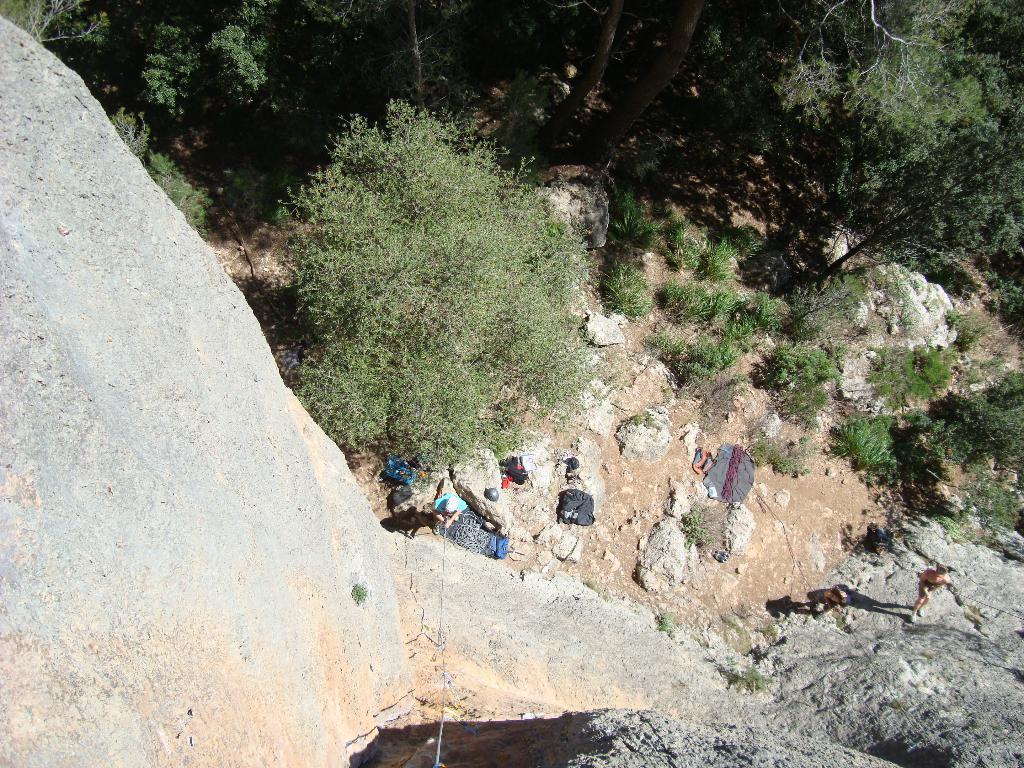How would you summarize this image in a sentence or two? In this image I can see number of trees, few bags, ropes, shadows and I can also see few people are standing. 